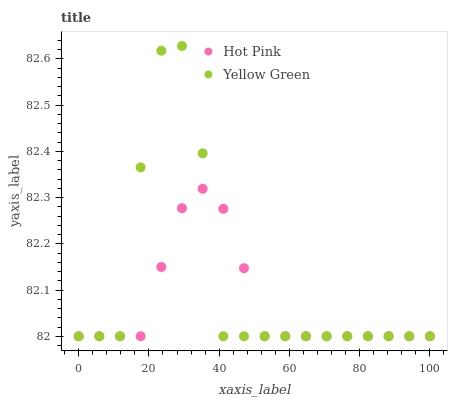Does Hot Pink have the minimum area under the curve?
Answer yes or no. Yes. Does Yellow Green have the maximum area under the curve?
Answer yes or no. Yes. Does Yellow Green have the minimum area under the curve?
Answer yes or no. No. Is Hot Pink the smoothest?
Answer yes or no. Yes. Is Yellow Green the roughest?
Answer yes or no. Yes. Is Yellow Green the smoothest?
Answer yes or no. No. Does Hot Pink have the lowest value?
Answer yes or no. Yes. Does Yellow Green have the highest value?
Answer yes or no. Yes. Does Yellow Green intersect Hot Pink?
Answer yes or no. Yes. Is Yellow Green less than Hot Pink?
Answer yes or no. No. Is Yellow Green greater than Hot Pink?
Answer yes or no. No. 